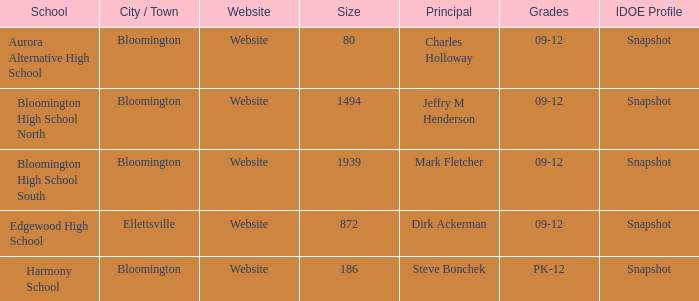Who's the principal of Edgewood High School?/ Dirk Ackerman. 